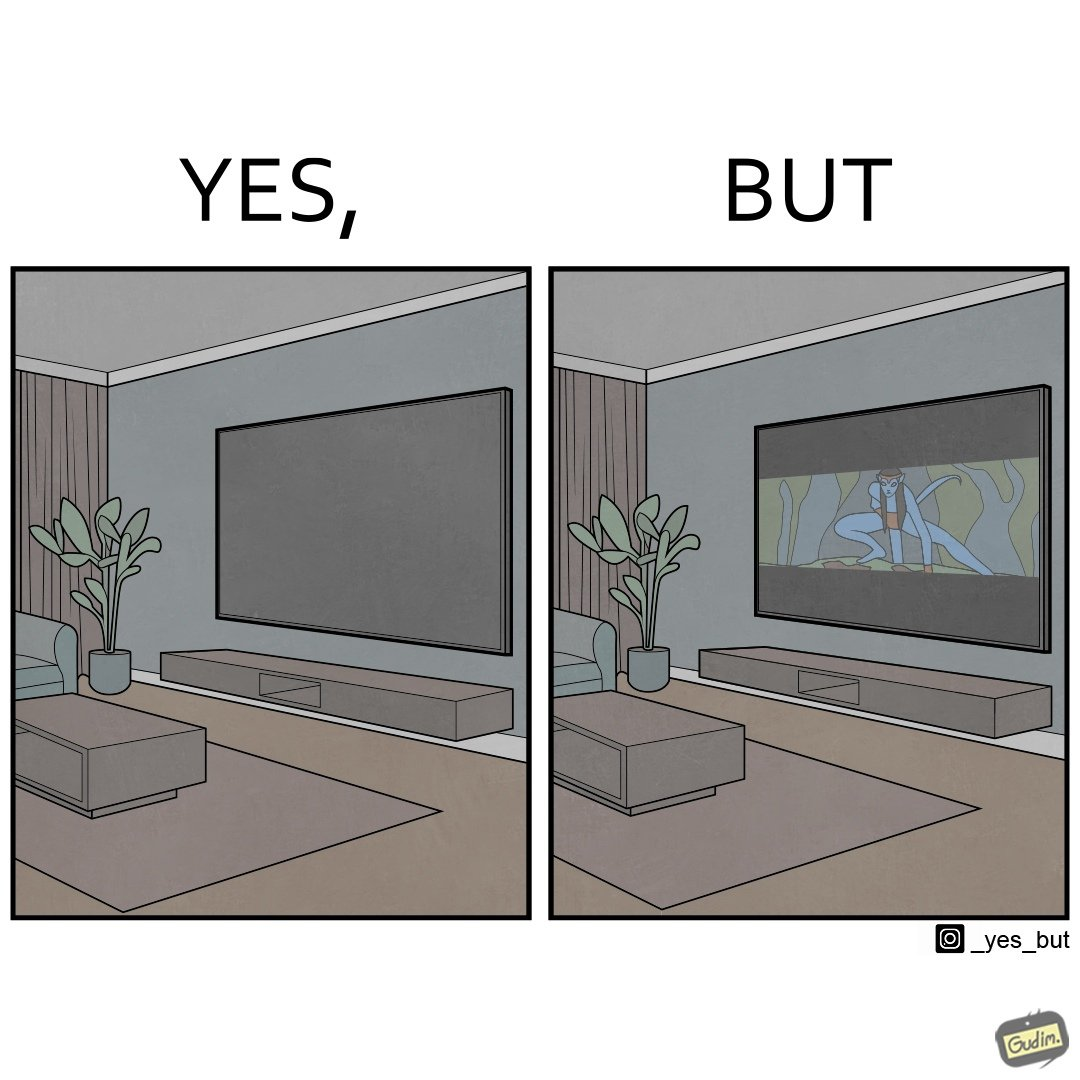Provide a description of this image. The image is funny because while the room has a big TV with a big screen, the movie being played on it does not use the entire screen. 